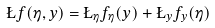<formula> <loc_0><loc_0><loc_500><loc_500>\L f ( \eta , y ) = \L _ { \eta } f _ { \eta } ( y ) + \L _ { y } f _ { y } ( \eta )</formula> 